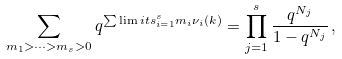Convert formula to latex. <formula><loc_0><loc_0><loc_500><loc_500>\sum _ { m _ { 1 } > \cdots > m _ { s } > 0 } q ^ { \sum \lim i t s _ { i = 1 } ^ { s } m _ { i } \nu _ { i } ( k ) } = \prod _ { j = 1 } ^ { s } \frac { q ^ { N _ { j } } } { 1 - q ^ { N _ { j } } } \, ,</formula> 